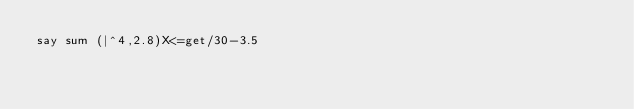Convert code to text. <code><loc_0><loc_0><loc_500><loc_500><_Perl_>say sum (|^4,2.8)X<=get/30-3.5</code> 